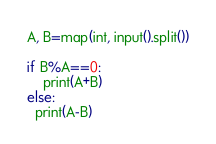Convert code to text. <code><loc_0><loc_0><loc_500><loc_500><_Python_>A, B=map(int, input().split())

if B%A==0:
    print(A+B)
else:
  print(A-B)</code> 